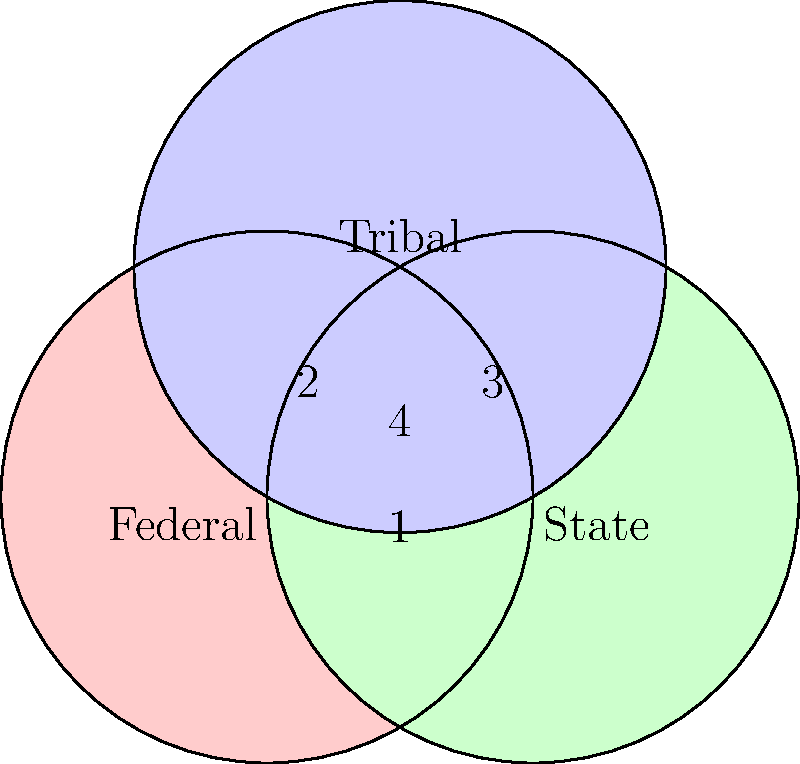In the Venn diagram above, federal, state, and tribal lands are represented by three overlapping circles. Which numbered region represents areas where all three jurisdictions potentially overlap, and what real-world scenario might this depict? To answer this question, let's analyze the Venn diagram step-by-step:

1. The red circle represents federal lands.
2. The green circle represents state lands.
3. The blue circle represents tribal lands.
4. The regions where circles overlap indicate areas of shared or overlapping jurisdiction.

5. Region 1: Overlap of federal and state lands only.
6. Region 2: Overlap of federal and tribal lands only.
7. Region 3: Overlap of state and tribal lands only.
8. Region 4: Overlap of all three circles, representing areas where federal, state, and tribal jurisdictions potentially intersect.

Therefore, region 4 is the area where all three jurisdictions potentially overlap.

A real-world scenario this might depict could be a case involving a sacred tribal site located within a national park (federal land) that is also partially within state boundaries. This situation could arise in states like Arizona, New Mexico, or Utah, where there are significant federal and tribal land holdings.

In such cases, there might be complex jurisdictional issues related to:
- Protection of cultural resources (tribal interest)
- Environmental regulations (federal and state interests)
- Law enforcement (potentially all three jurisdictions)
- Land use and development rights

These overlapping jurisdictions often require careful negotiation and sometimes lead to legal disputes that a federal prosecutor might encounter.
Answer: Region 4; e.g., a sacred tribal site within a national park and state boundaries. 